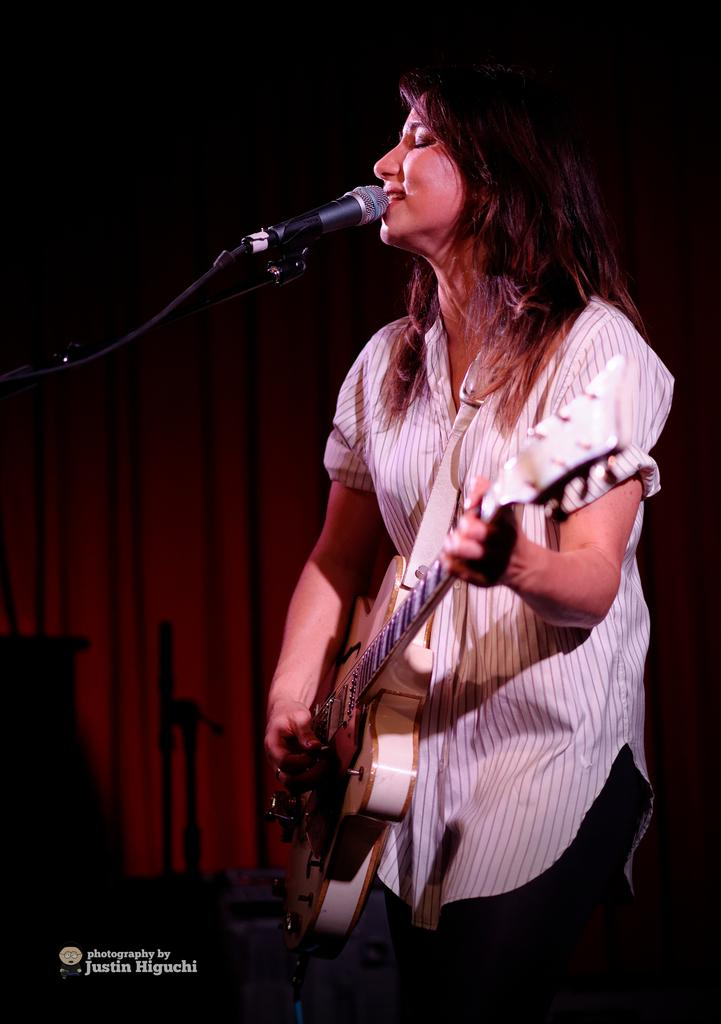Who is the main subject in the image? There is a woman in the image. What is the woman doing in the image? The woman is playing a guitar and singing a song. What object is present in front of the woman? There is a microphone present in front of the woman. What type of leather is visible on the table in the image? There is no table or leather present in the image; it features a woman playing a guitar and singing with a microphone in front of her. 